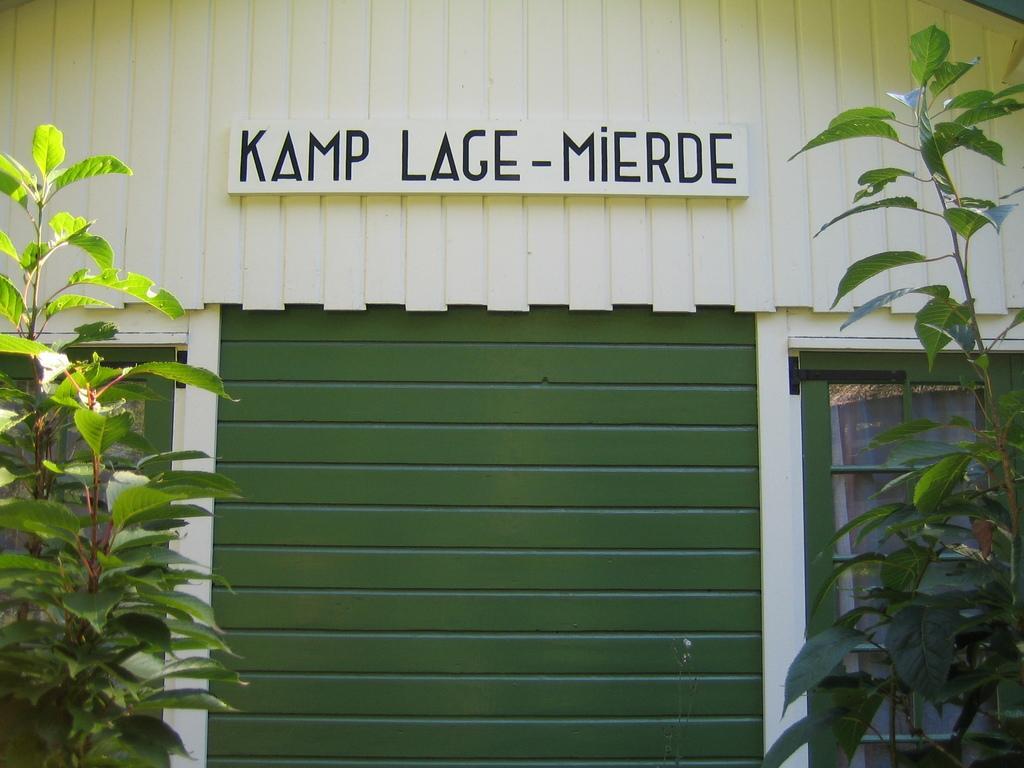Describe this image in one or two sentences. There is a compartment and it has two windows on the either side and in front of the compartment there are two plants. 